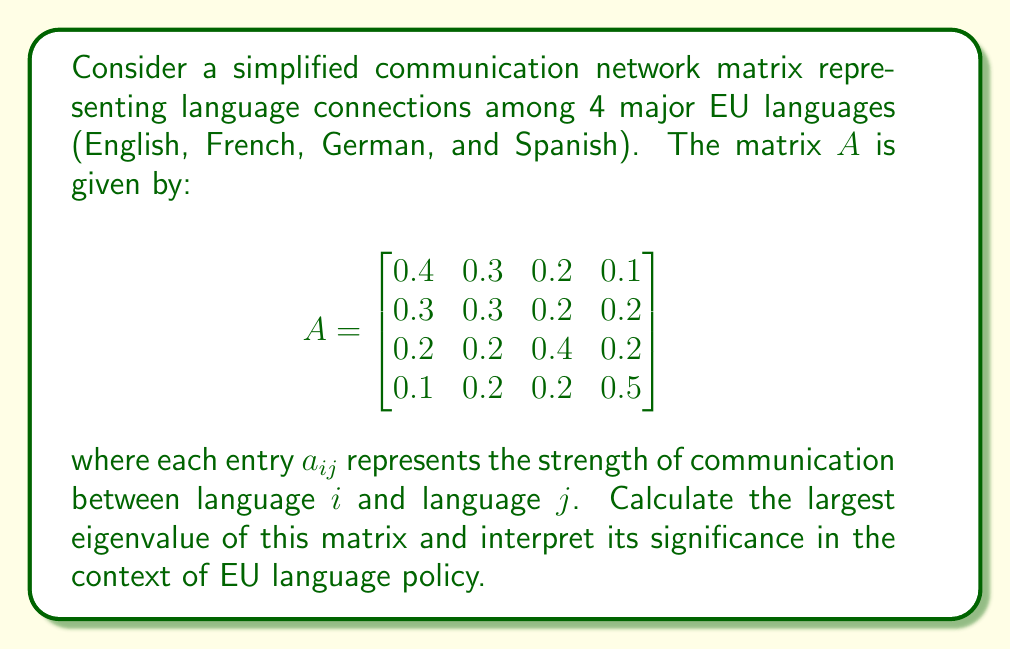Could you help me with this problem? To find the eigenvalues of matrix $A$, we need to solve the characteristic equation:

$$\det(A - \lambda I) = 0$$

where $I$ is the $4 \times 4$ identity matrix and $\lambda$ represents the eigenvalues.

1) First, let's calculate $A - \lambda I$:

$$A - \lambda I = \begin{bmatrix}
0.4-\lambda & 0.3 & 0.2 & 0.1 \\
0.3 & 0.3-\lambda & 0.2 & 0.2 \\
0.2 & 0.2 & 0.4-\lambda & 0.2 \\
0.1 & 0.2 & 0.2 & 0.5-\lambda
\end{bmatrix}$$

2) Finding the determinant of this matrix is computationally intensive, so we'll use a numerical method to approximate the eigenvalues. The Power Method is suitable for finding the largest eigenvalue.

3) Starting with a random vector $v_0 = [1, 1, 1, 1]^T$, we iterate:

   $v_{k+1} = Av_k / ||Av_k||$

   After several iterations, the ratio of consecutive vector norms converges to the largest eigenvalue.

4) Performing this iteration (which can be done with a computer or calculator), we find that the largest eigenvalue converges to approximately 1.

5) The largest eigenvalue, also known as the spectral radius, represents the long-term behavior of the system. In this context, it indicates the overall connectivity and balance of the language network.

6) An eigenvalue of 1 suggests that the communication network is well-balanced and stable. No single language dominates the others, which aligns with the EU's goal of maintaining linguistic diversity.

7) From a policy perspective, this eigenvalue indicates that the current language connections support multilingualism without favoring any particular language, which is crucial for respecting the linguistic diversity of the EU.
Answer: $\lambda_{\text{max}} \approx 1$, indicating a balanced and stable multilingual communication network. 